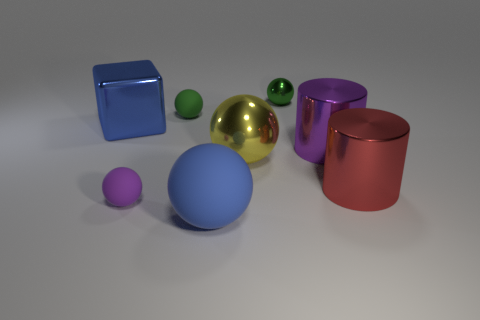What is the color of the tiny metal thing that is the same shape as the large blue matte object?
Ensure brevity in your answer.  Green. What number of things are large shiny spheres or small cyan metal cylinders?
Provide a succinct answer. 1. What is the shape of the tiny green thing that is made of the same material as the large purple object?
Offer a terse response. Sphere. What number of tiny things are blue blocks or red cylinders?
Provide a succinct answer. 0. What number of other objects are there of the same color as the large metallic block?
Offer a very short reply. 1. There is a large blue thing to the right of the green object to the left of the green metal ball; what number of blue cubes are on the left side of it?
Provide a short and direct response. 1. There is a metallic sphere left of the green metallic ball; does it have the same size as the large blue shiny object?
Provide a short and direct response. Yes. Is the number of large blue objects that are in front of the blue metallic object less than the number of things that are behind the large red shiny cylinder?
Offer a very short reply. Yes. Is the color of the shiny cube the same as the big matte sphere?
Offer a terse response. Yes. Is the number of small green balls on the left side of the tiny shiny sphere less than the number of purple cylinders?
Offer a terse response. No. 